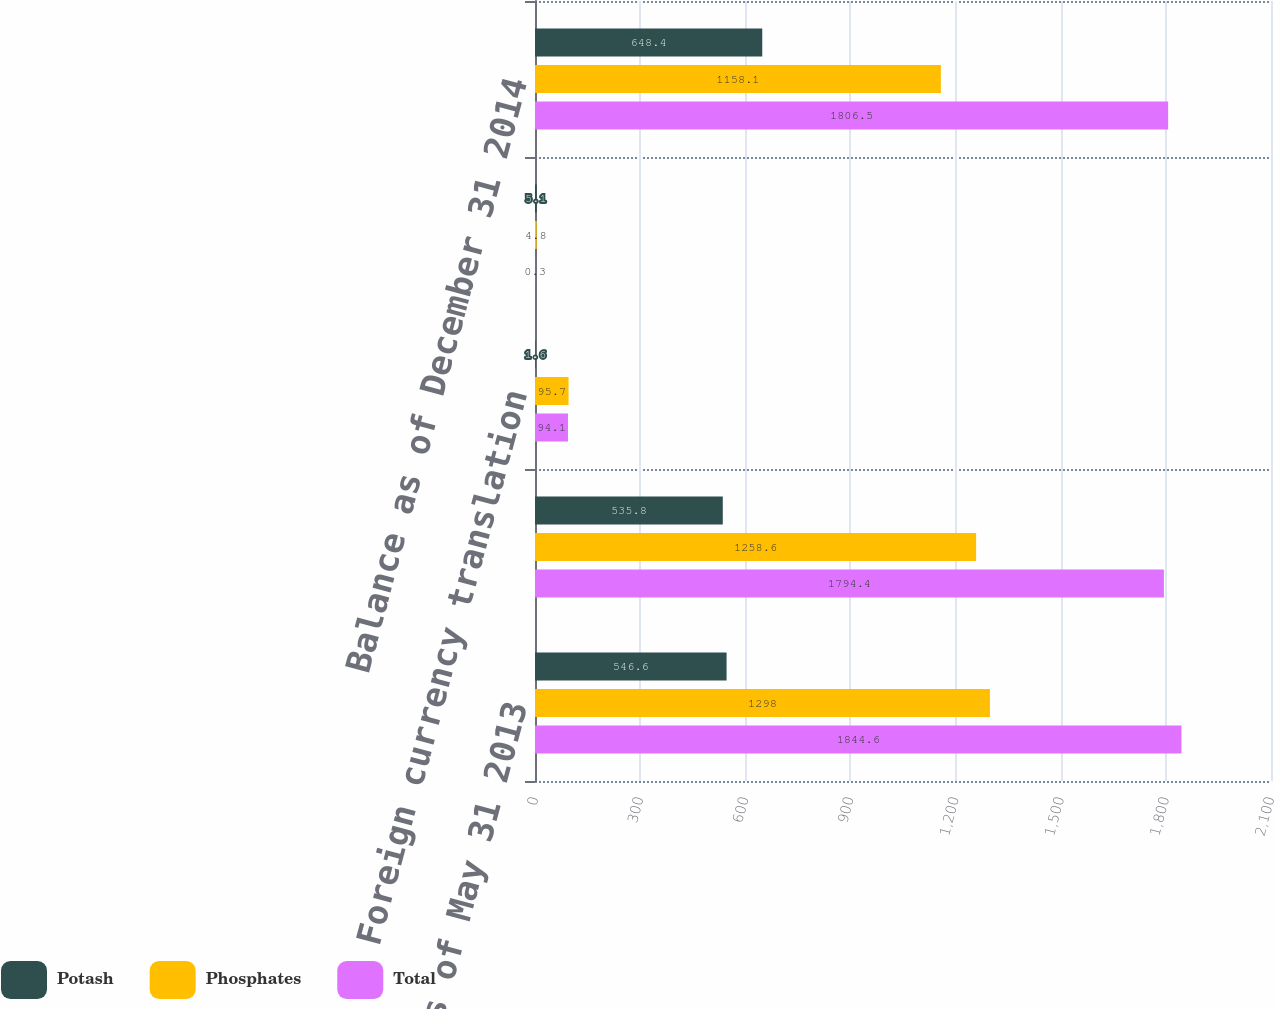Convert chart. <chart><loc_0><loc_0><loc_500><loc_500><stacked_bar_chart><ecel><fcel>Balance as of May 31 2013<fcel>Balance at December 31 2013<fcel>Foreign currency translation<fcel>Reallocation of goodwill to<fcel>Balance as of December 31 2014<nl><fcel>Potash<fcel>546.6<fcel>535.8<fcel>1.6<fcel>5.1<fcel>648.4<nl><fcel>Phosphates<fcel>1298<fcel>1258.6<fcel>95.7<fcel>4.8<fcel>1158.1<nl><fcel>Total<fcel>1844.6<fcel>1794.4<fcel>94.1<fcel>0.3<fcel>1806.5<nl></chart> 